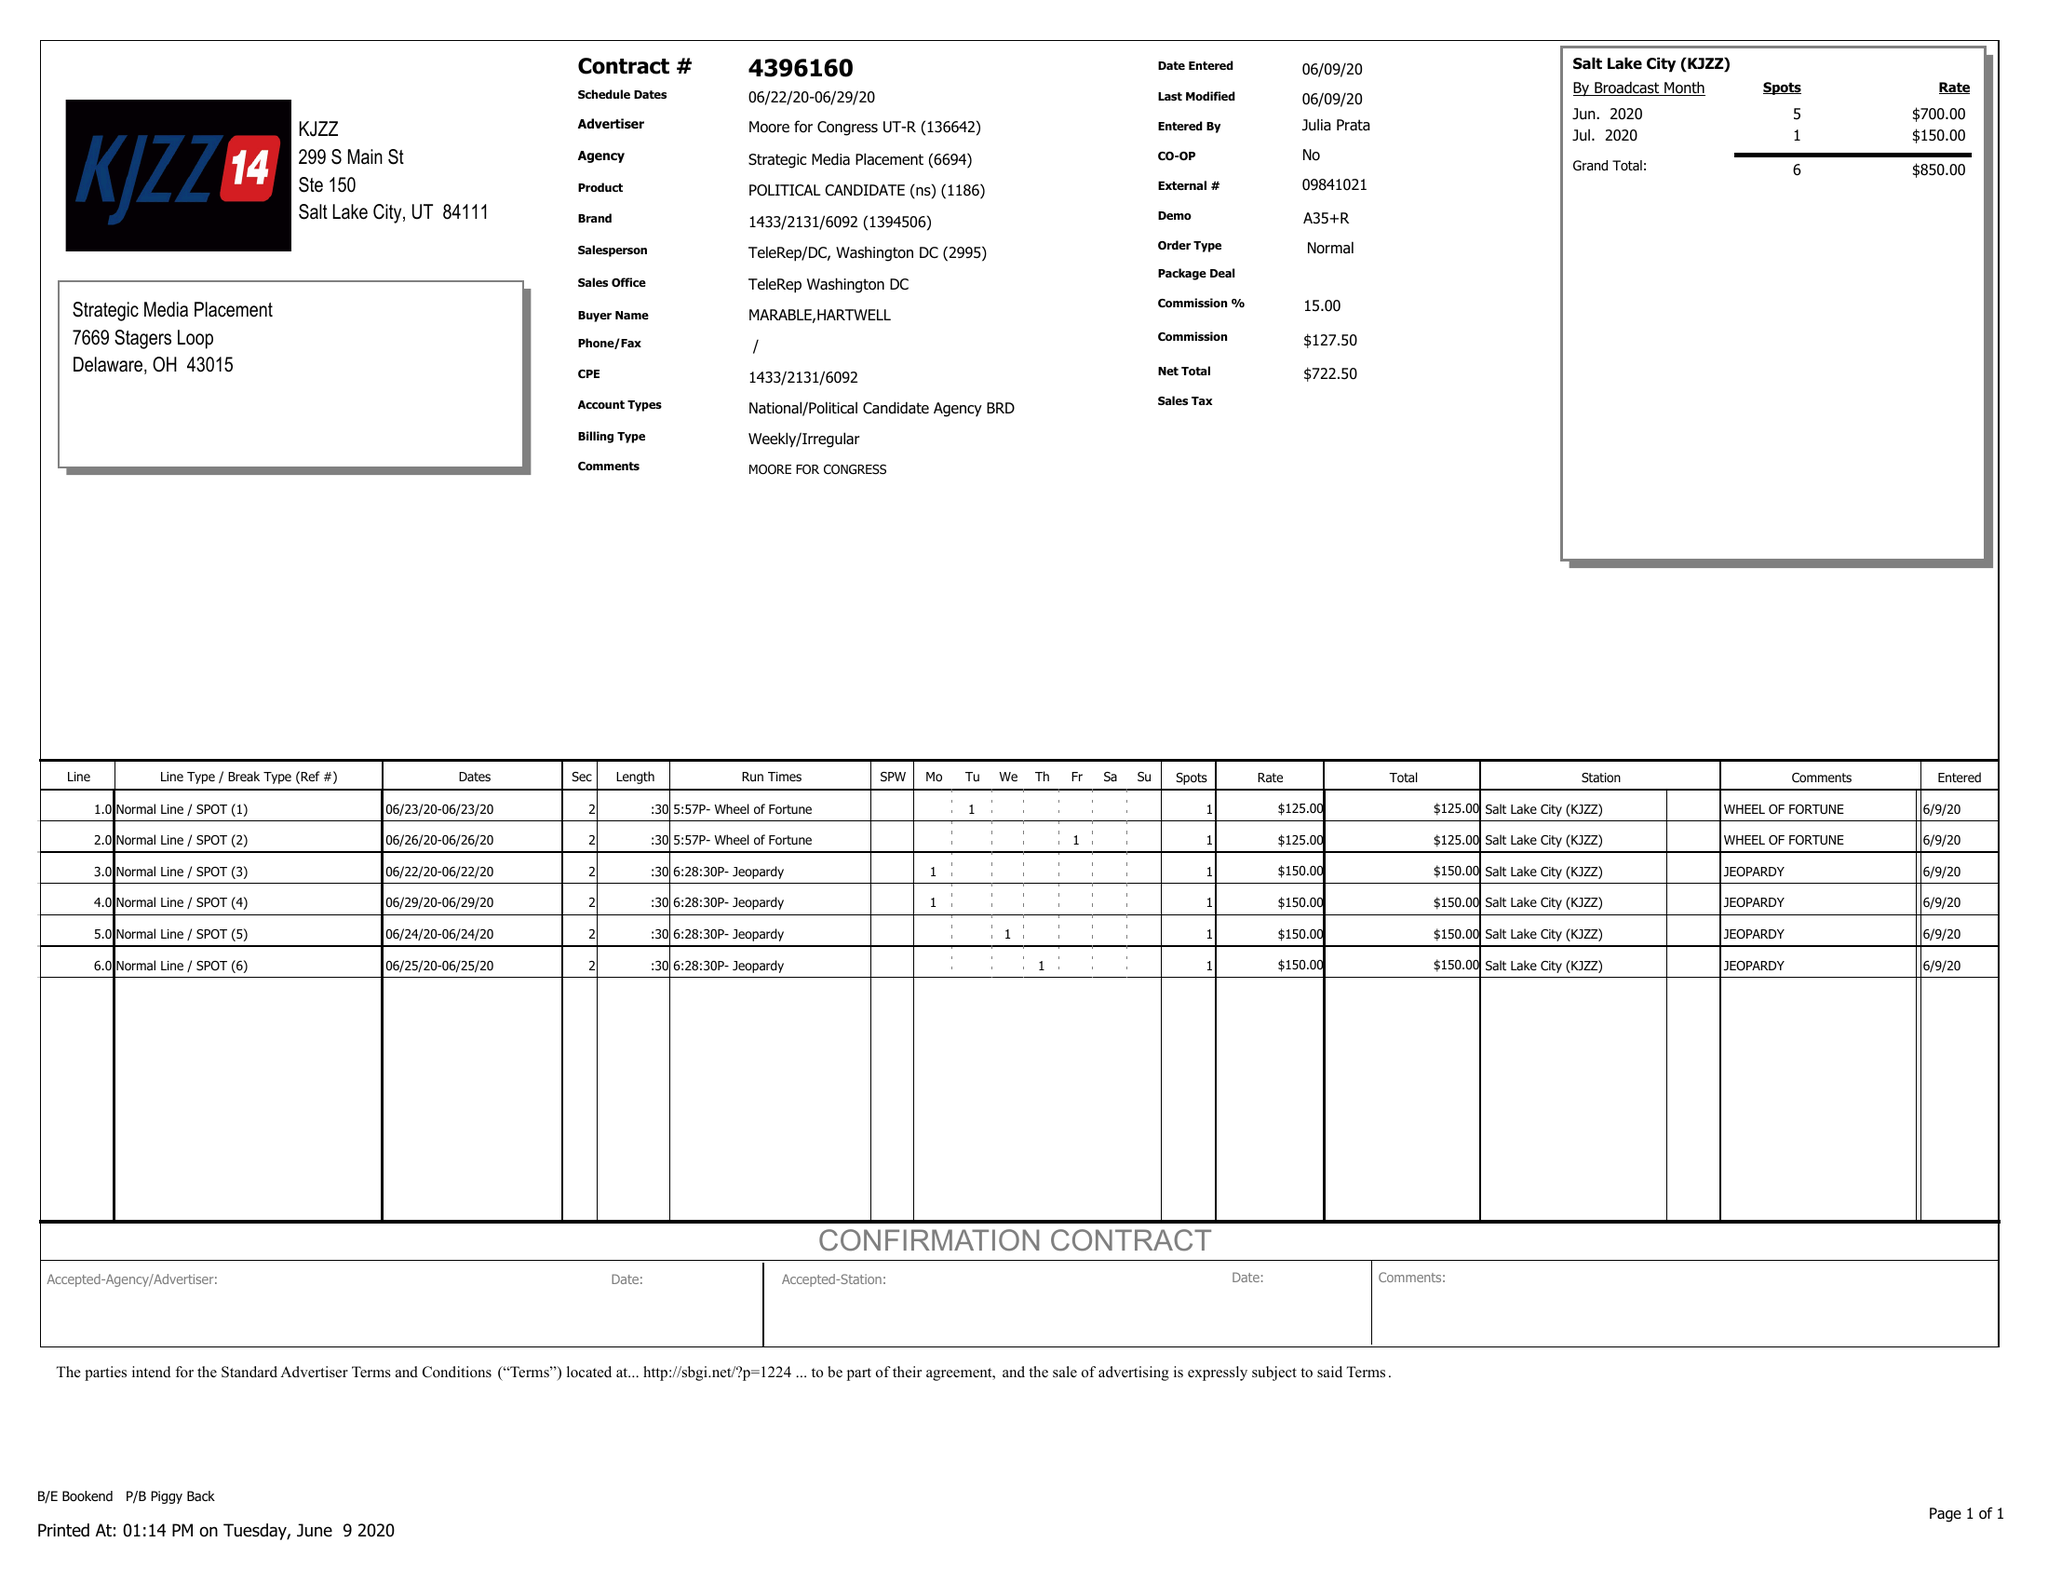What is the value for the gross_amount?
Answer the question using a single word or phrase. 850.00 